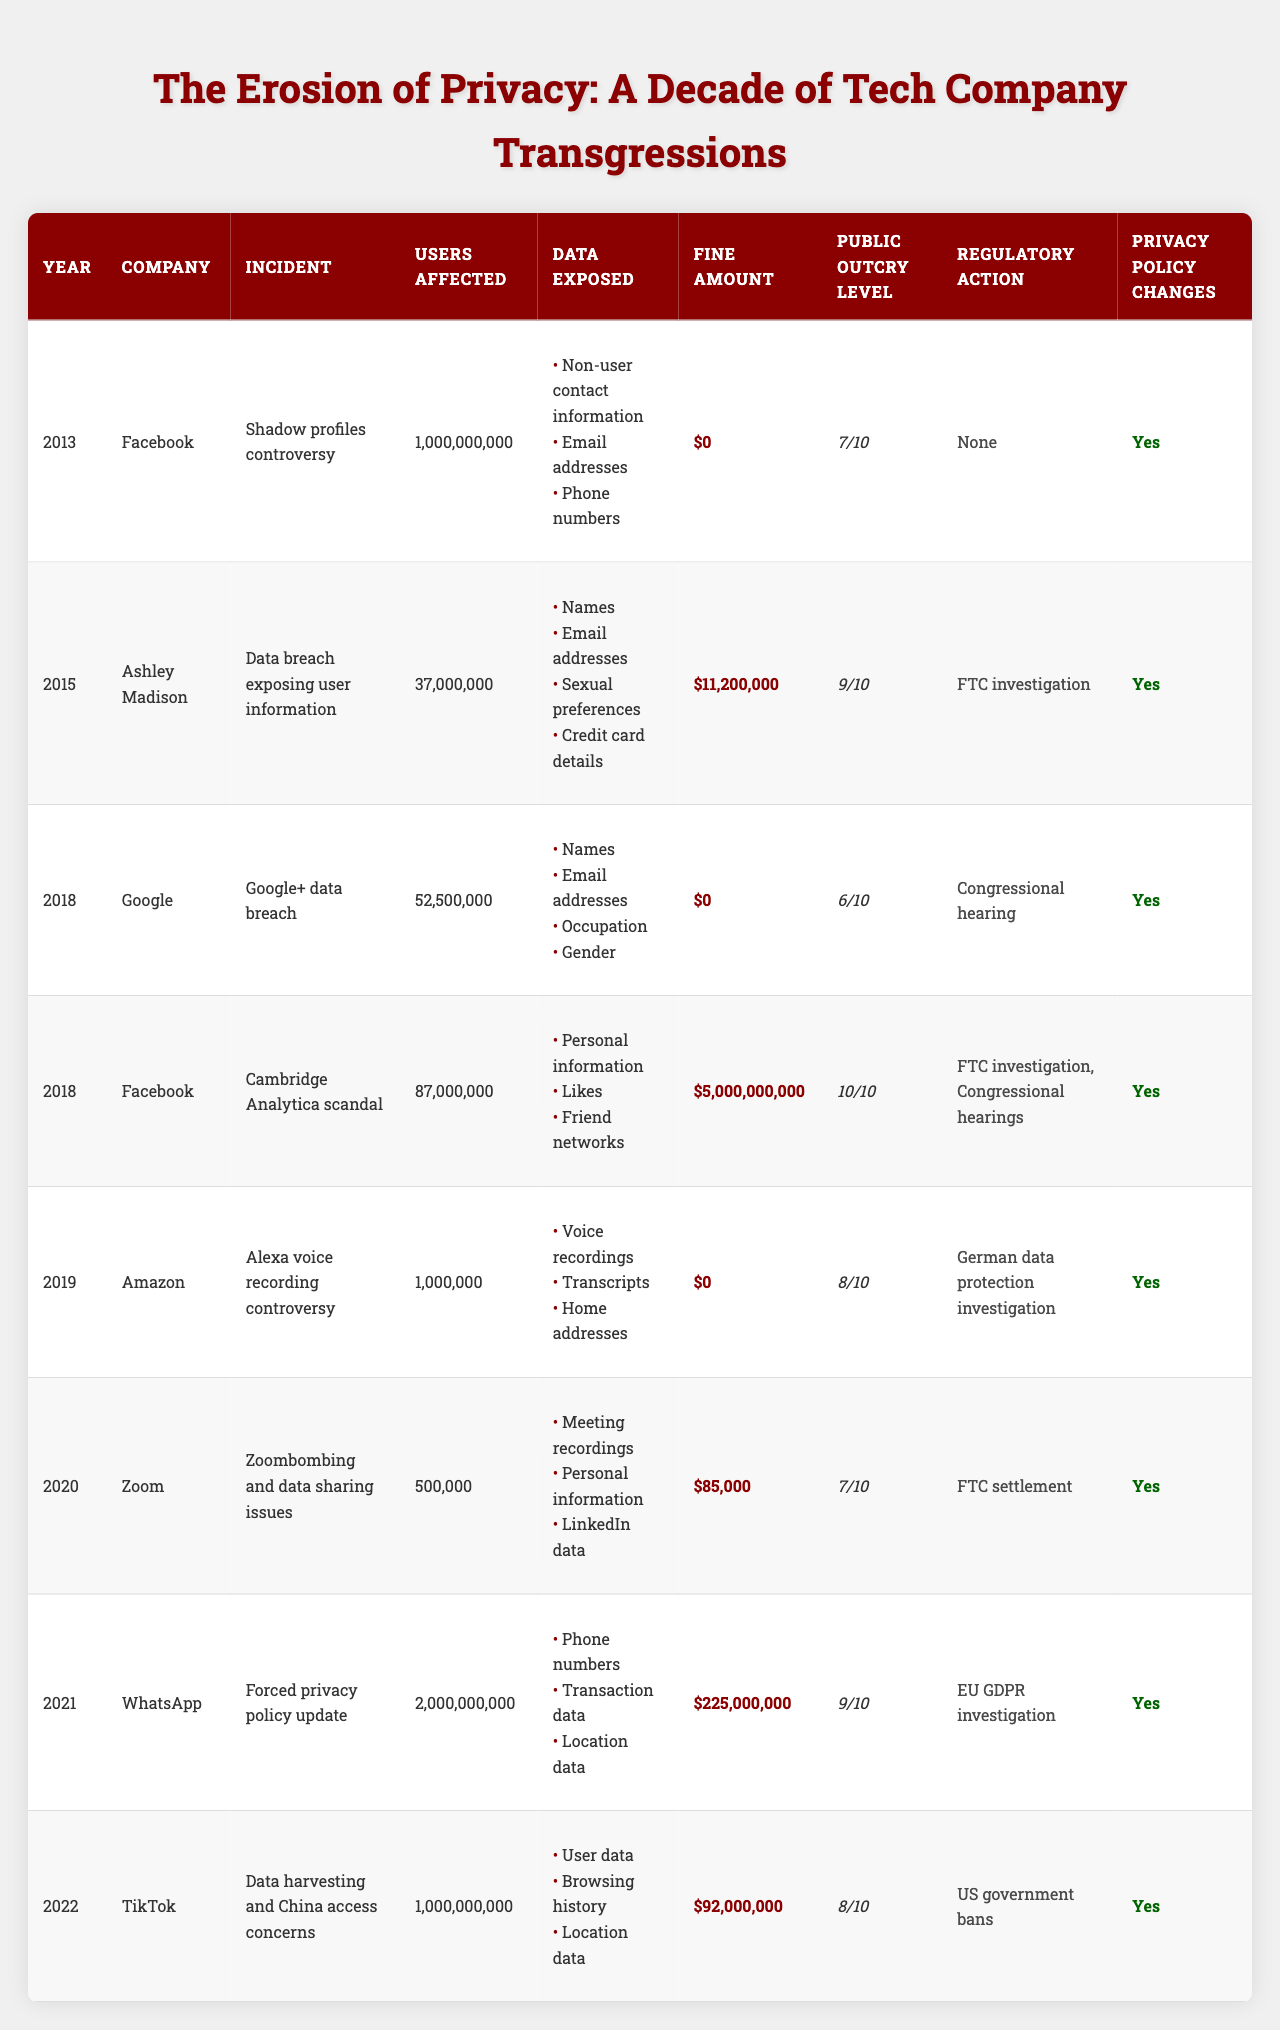What incident in 2018 had the highest public outcry level? In 2018, the Cambridge Analytica scandal involving Facebook had a public outcry level of 10, which is the highest in that year.
Answer: Cambridge Analytica scandal Which company was fined the most in this table? The highest fine amount recorded in the table is $5,000,000,000 for Facebook related to the Cambridge Analytica scandal.
Answer: Facebook How many users were affected in incidents involving data breaches from 2015? The Ashley Madison data breach in 2015 affected 37,000,000 users. This is the only incident from that year in the table.
Answer: 37,000,000 Did Amazon change its privacy policy after the Alexa controversy? Yes, Amazon did make changes to its privacy policy following the controversy regarding Alexa voice recordings.
Answer: Yes What was the average number of users affected across all incidents listed? The total number of users affected across all incidents is 2,162,500,000, and there are 8 incidents listed, so the average is 2,162,500,000 / 8 = 270,312,500.
Answer: 270,312,500 Which incident had the least number of users affected? The incident with the least number of users affected is the Zoom incident in 2020, which involved 500,000 users.
Answer: Zoom incident How many incidents involved regulatory actions? By examining the table, it is found that all incidents except for the Facebook Shadow profiles controversy had some form of regulatory action, making it 7 out of 8 incidents.
Answer: 7 Which year had the most incidents recorded in the table? The incidents are distributed across the years, but there's no year with more than one incident listed in the data, indicating each year primarily had one incident.
Answer: No year with multiple incidents What percentage of the incidents involved changes to privacy policies? Out of the 8 incidents listed, all 8 involved changes to privacy policies, resulting in 100% of the incidents showing policy changes.
Answer: 100% 